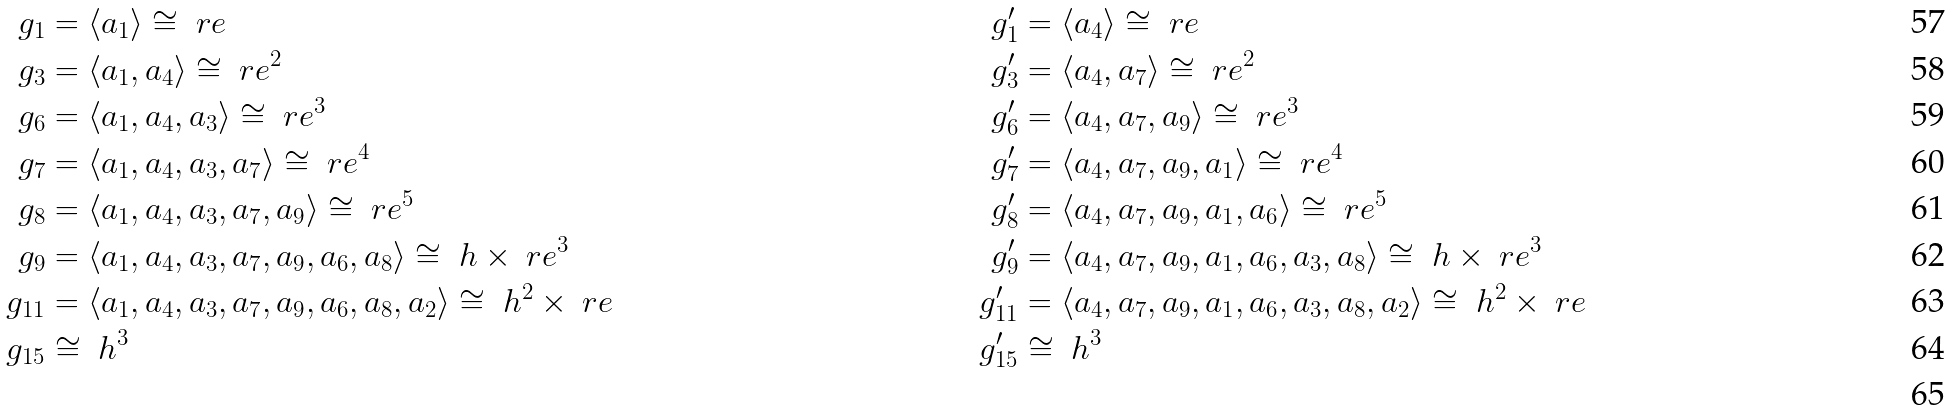<formula> <loc_0><loc_0><loc_500><loc_500>\ g _ { 1 } & = \langle a _ { 1 } \rangle \cong \ r e & \ g ^ { \prime } _ { 1 } & = \langle a _ { 4 } \rangle \cong \ r e \\ \ g _ { 3 } & = \langle a _ { 1 } , a _ { 4 } \rangle \cong \ r e ^ { 2 } & \ g ^ { \prime } _ { 3 } & = \langle a _ { 4 } , a _ { 7 } \rangle \cong \ r e ^ { 2 } \\ \ g _ { 6 } & = \langle a _ { 1 } , a _ { 4 } , a _ { 3 } \rangle \cong \ r e ^ { 3 } & \ g ^ { \prime } _ { 6 } & = \langle a _ { 4 } , a _ { 7 } , a _ { 9 } \rangle \cong \ r e ^ { 3 } \\ \ g _ { 7 } & = \langle a _ { 1 } , a _ { 4 } , a _ { 3 } , a _ { 7 } \rangle \cong \ r e ^ { 4 } & \ g ^ { \prime } _ { 7 } & = \langle a _ { 4 } , a _ { 7 } , a _ { 9 } , a _ { 1 } \rangle \cong \ r e ^ { 4 } \\ \ g _ { 8 } & = \langle a _ { 1 } , a _ { 4 } , a _ { 3 } , a _ { 7 } , a _ { 9 } \rangle \cong \ r e ^ { 5 } & \ g ^ { \prime } _ { 8 } & = \langle a _ { 4 } , a _ { 7 } , a _ { 9 } , a _ { 1 } , a _ { 6 } \rangle \cong \ r e ^ { 5 } \\ \ g _ { 9 } & = \langle a _ { 1 } , a _ { 4 } , a _ { 3 } , a _ { 7 } , a _ { 9 } , a _ { 6 } , a _ { 8 } \rangle \cong \ h \times \ r e ^ { 3 } & \ g ^ { \prime } _ { 9 } & = \langle a _ { 4 } , a _ { 7 } , a _ { 9 } , a _ { 1 } , a _ { 6 } , a _ { 3 } , a _ { 8 } \rangle \cong \ h \times \ r e ^ { 3 } \\ \ g _ { 1 1 } & = \langle a _ { 1 } , a _ { 4 } , a _ { 3 } , a _ { 7 } , a _ { 9 } , a _ { 6 } , a _ { 8 } , a _ { 2 } \rangle \cong \ h ^ { 2 } \times \ r e & \ g ^ { \prime } _ { 1 1 } & = \langle a _ { 4 } , a _ { 7 } , a _ { 9 } , a _ { 1 } , a _ { 6 } , a _ { 3 } , a _ { 8 } , a _ { 2 } \rangle \cong \ h ^ { 2 } \times \ r e \\ \ g _ { 1 5 } & \cong \ h ^ { 3 } & \ g ^ { \prime } _ { 1 5 } & \cong \ h ^ { 3 } \\</formula> 